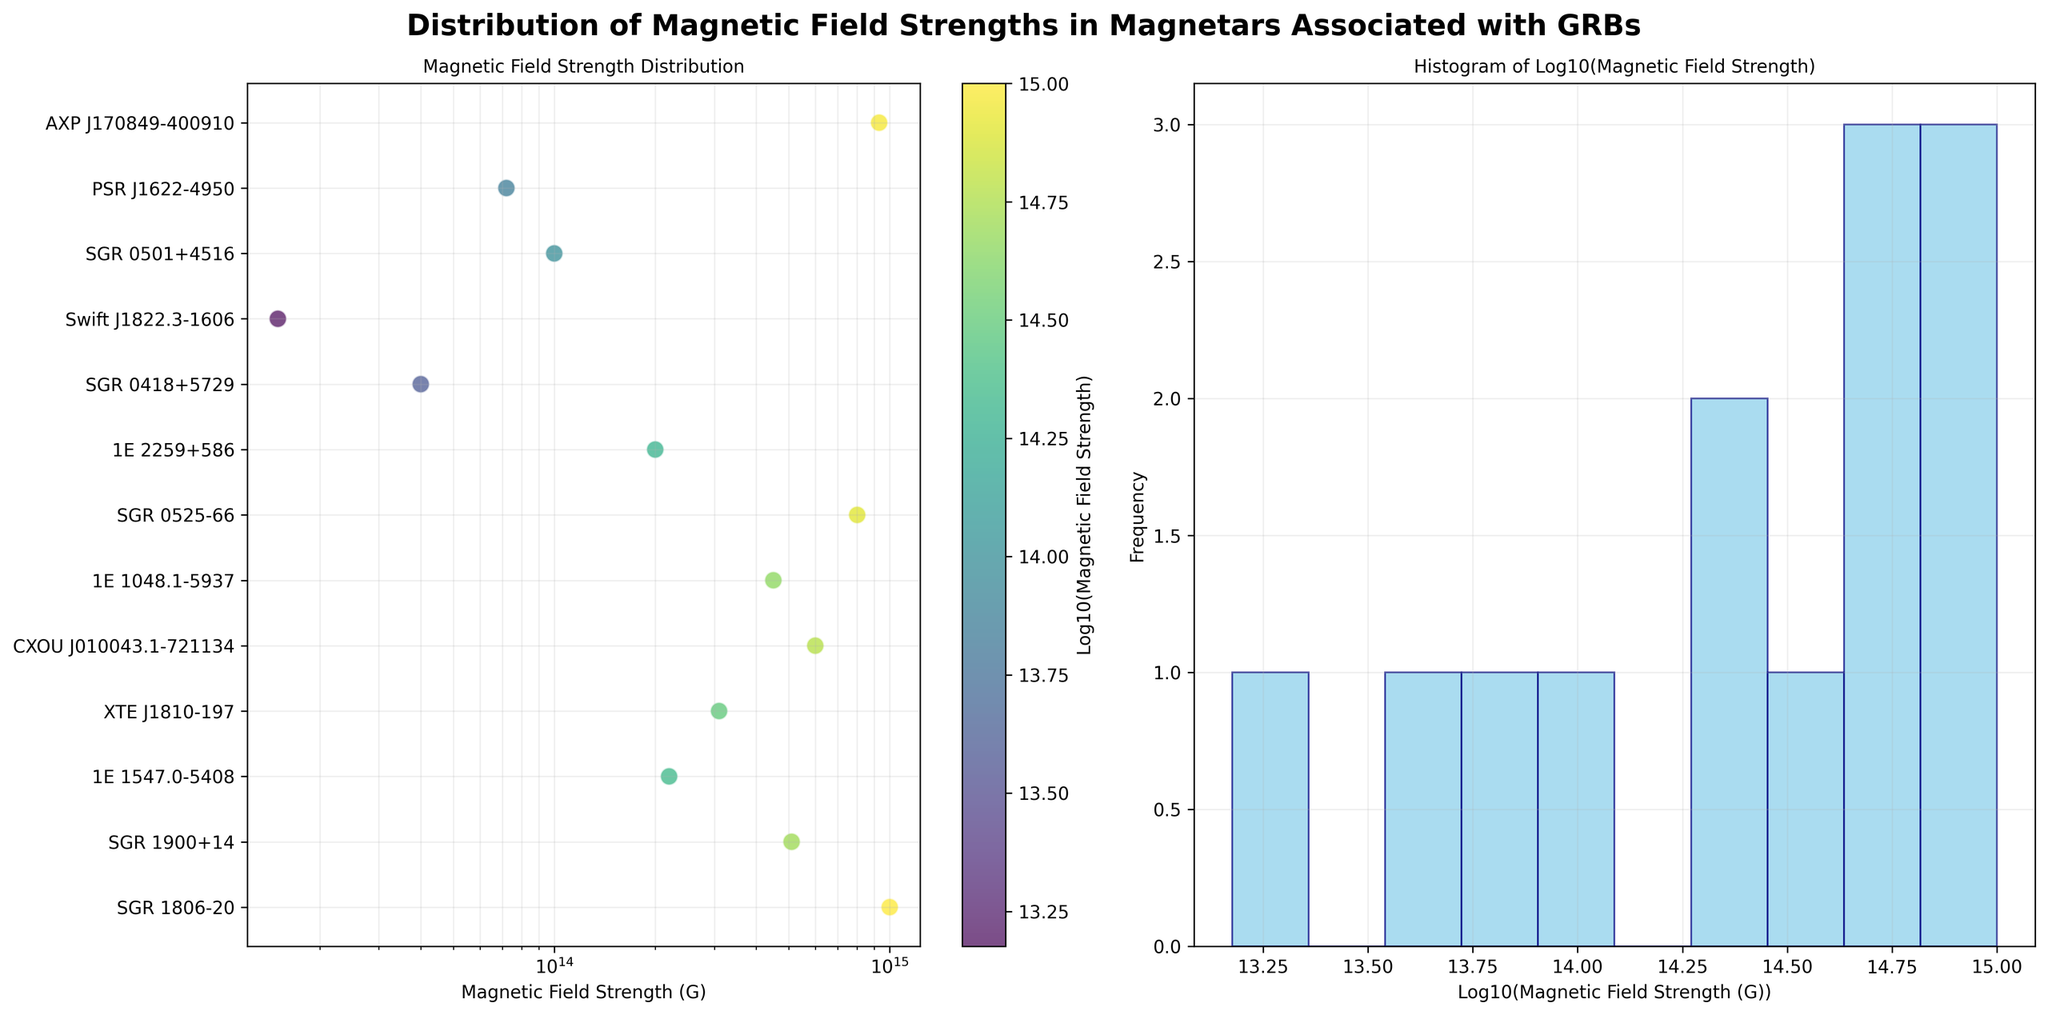what is the overall title of the figure? The title is written in bold at the top of the figure. It reads, "Distribution of Magnetic Field Strengths in Magnetars Associated with GRBs."
Answer: Distribution of Magnetic Field Strengths in Magnetars Associated with GRBs What are the x-axes labeled in both subplots? The labels are written at the bottom of each x-axis. The left subplot's x-axis is labeled "Magnetic Field Strength (G)", and the right subplot's x-axis is labeled "Log10(Magnetic Field Strength (G))".
Answer: Magnetic Field Strength (G), Log10(Magnetic Field Strength (G)) How many magnetars are depicted in the figure? The left subplot lists the names of all the magnetars along the y-axis. Counting the number of tick marks with corresponding names gives us the total number of magnetars depicted.
Answer: 13 What is the color gradient in the scatter plot representing? The color gradient in the scatter plot is shown in a color bar beside the plot. It is labeled "Log10(Magnetic Field Strength)" indicating that the color intensity represents the logarithm of the magnetic field strength.
Answer: Log10(Magnetic Field Strength) Which magnetar has the highest magnetic field strength in the figure? In the scatter plot, look for the data point farthest to the right which corresponds to the highest magnetic field strength. The y-axis label of this point gives the name of the magnetar.
Answer: SGR 1806-20 How many magnetars have a magnetic field strength above 1E+14 G? From the scatter plot, count the number of data points that fall to the right of the 1E+14 G mark on the x-axis.
Answer: 7 Which magnetar has the lowest magnetic field strength, and what is this value? In the scatter plot, the point farthest to the left represents the lowest magnetic field strength. The corresponding y-axis label gives the name of the magnetar, and the x-axis value of this point gives the magnetic field strength.
Answer: Swift J1822.3-1606, 1.5E+13 G How many bins are used in the histogram of the right subplot? The histogram in the right subplot has vertical bars that represent the bins. Counting the number of distinct bars gives the number of bins used.
Answer: 10 What is the most common logarithmic value of magnetic field strength depicted in the histogram? In the right subplot, the bar with the highest frequency represents the most common logarithmic value of magnetic field strength. Look for the range on the x-axis that corresponds to this bar.
Answer: Between 13 and 14 (Log10 value) Which magnetar is associated with GRB 090424, and what is its magnetic field strength? In the left subplot, check the y-axis for the magnetar associated with GRB 090424. The corresponding x-axis value gives the magnetic field strength.
Answer: AXP J170849-400910, 9.3E+14 G 